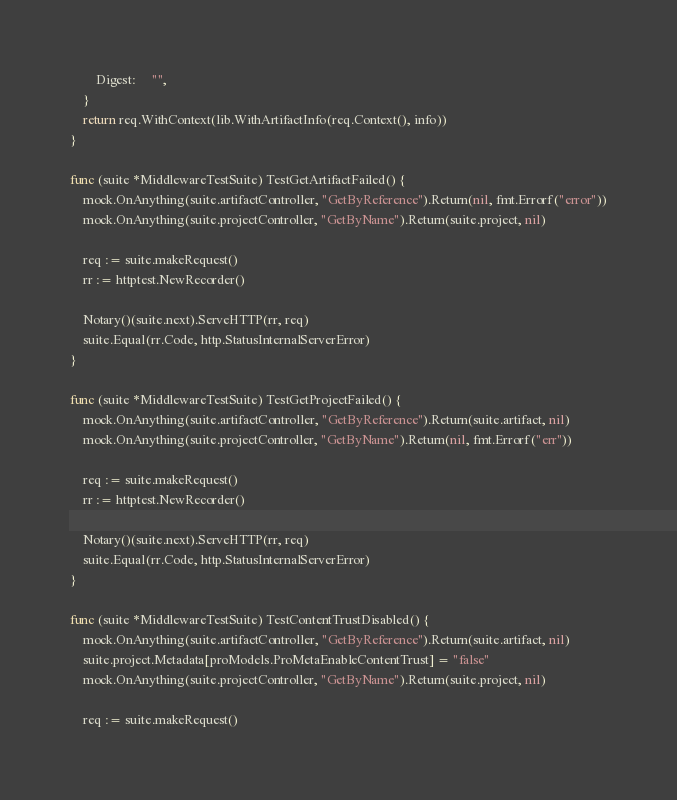Convert code to text. <code><loc_0><loc_0><loc_500><loc_500><_Go_>		Digest:     "",
	}
	return req.WithContext(lib.WithArtifactInfo(req.Context(), info))
}

func (suite *MiddlewareTestSuite) TestGetArtifactFailed() {
	mock.OnAnything(suite.artifactController, "GetByReference").Return(nil, fmt.Errorf("error"))
	mock.OnAnything(suite.projectController, "GetByName").Return(suite.project, nil)

	req := suite.makeRequest()
	rr := httptest.NewRecorder()

	Notary()(suite.next).ServeHTTP(rr, req)
	suite.Equal(rr.Code, http.StatusInternalServerError)
}

func (suite *MiddlewareTestSuite) TestGetProjectFailed() {
	mock.OnAnything(suite.artifactController, "GetByReference").Return(suite.artifact, nil)
	mock.OnAnything(suite.projectController, "GetByName").Return(nil, fmt.Errorf("err"))

	req := suite.makeRequest()
	rr := httptest.NewRecorder()

	Notary()(suite.next).ServeHTTP(rr, req)
	suite.Equal(rr.Code, http.StatusInternalServerError)
}

func (suite *MiddlewareTestSuite) TestContentTrustDisabled() {
	mock.OnAnything(suite.artifactController, "GetByReference").Return(suite.artifact, nil)
	suite.project.Metadata[proModels.ProMetaEnableContentTrust] = "false"
	mock.OnAnything(suite.projectController, "GetByName").Return(suite.project, nil)

	req := suite.makeRequest()</code> 